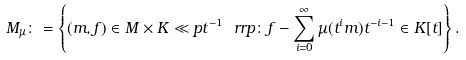<formula> <loc_0><loc_0><loc_500><loc_500>M _ { \mu } \colon = \left \{ ( m , f ) \in M \times K \ll p t ^ { - 1 } \ r r p \colon f - \sum _ { i = 0 } ^ { \infty } \mu ( t ^ { i } m ) t ^ { - i - 1 } \in K [ t ] \right \} .</formula> 